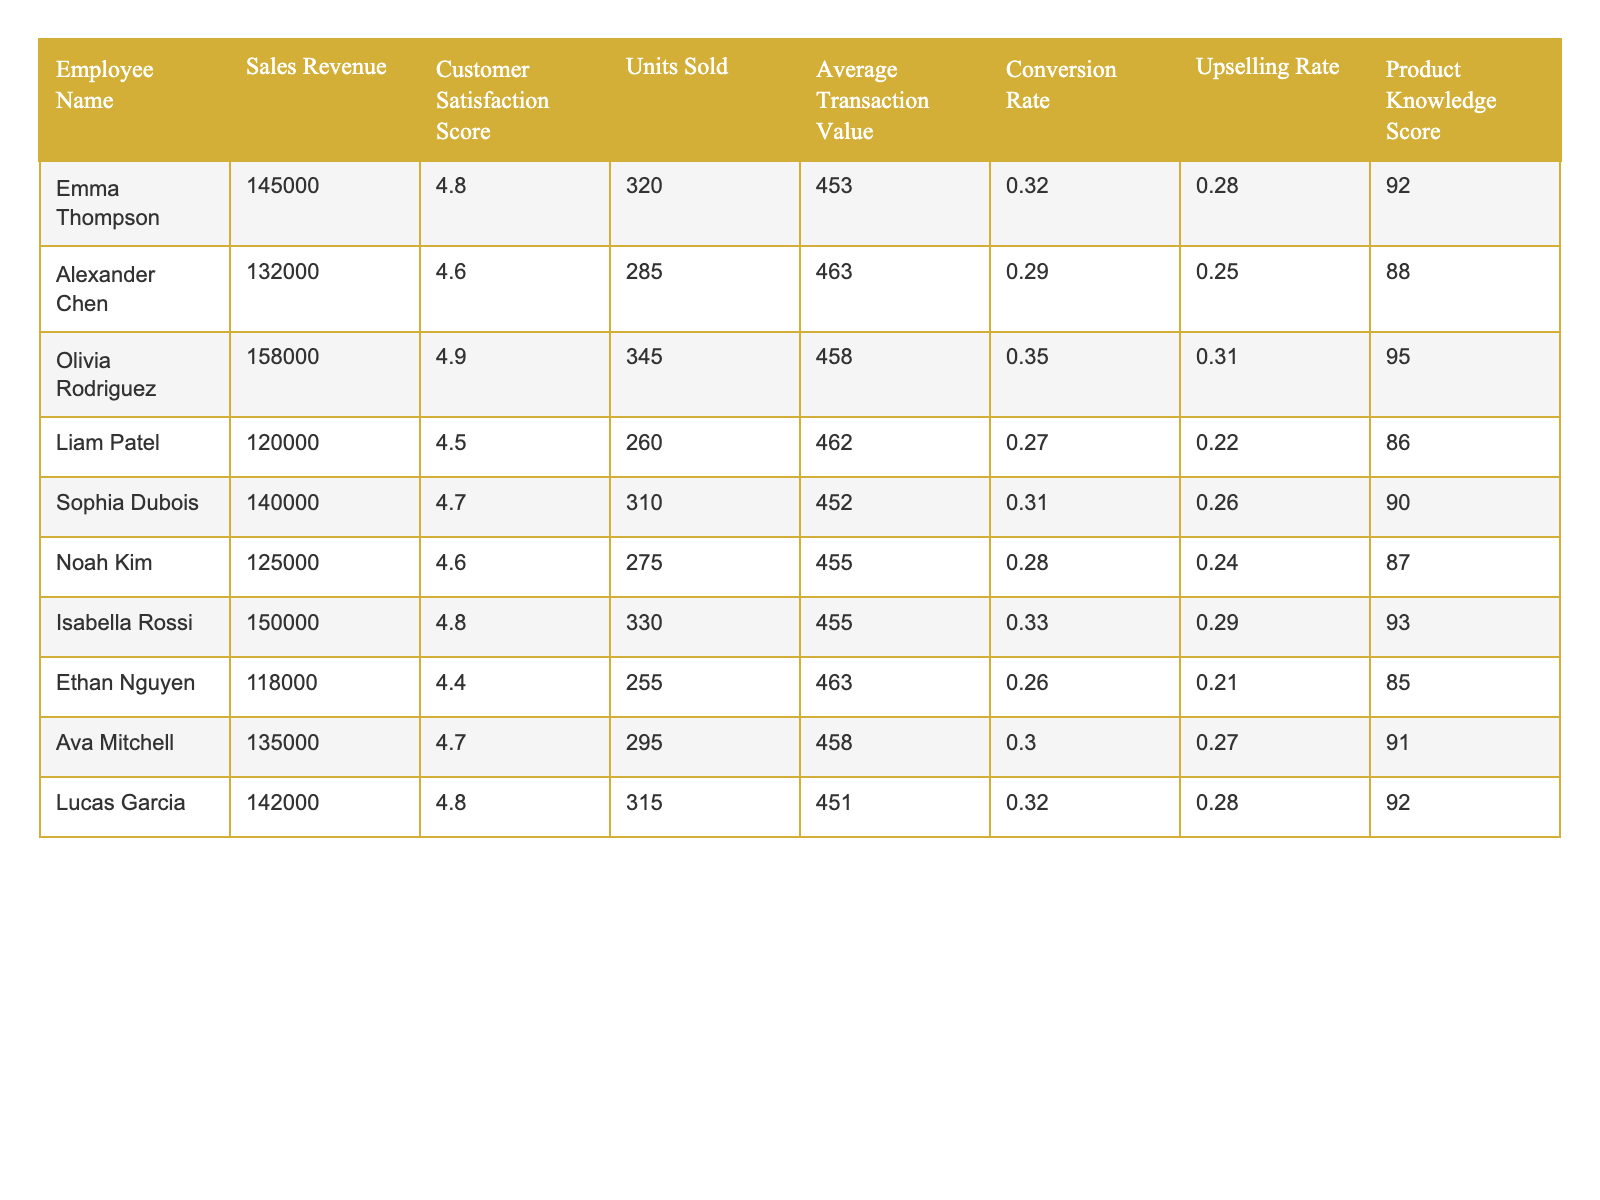What is the sales revenue of Olivia Rodriguez? The table indicates that Olivia Rodriguez has a sales revenue of 158000.
Answer: 158000 Who has the highest customer satisfaction score? According to the table, Olivia Rodriguez has the highest customer satisfaction score of 4.9.
Answer: 4.9 What is the average transaction value for Emma Thompson? The table shows that the average transaction value for Emma Thompson is 453.
Answer: 453 How many units did Liam Patel sell? The data in the table shows that Liam Patel sold 260 units.
Answer: 260 What is the conversion rate for Isabella Rossi? The table states that Isabella Rossi has a conversion rate of 0.33.
Answer: 0.33 What is the total sales revenue generated by the top three sales associates? Summing up the sales revenue of the top three associates: 158000 (Olivia) + 150000 (Isabella) + 145000 (Emma) gives 453000.
Answer: 453000 Is the average customer satisfaction score for the employees above 4.6? To find the average, we calculate: (4.8 + 4.6 + 4.9 + 4.5 + 4.7 + 4.6 + 4.8 + 4.4 + 4.7 + 4.8) / 10 = 4.66, which is below 4.6. So, the answer is no.
Answer: No Who has the highest upselling rate and what is it? From the table, Isabella Rossi has the highest upselling rate of 0.29.
Answer: 0.29 If we consider the conversion rates of all employees, what is the overall average conversion rate? Adding up all conversion rates: 0.32 + 0.29 + 0.35 + 0.27 + 0.31 + 0.28 + 0.33 + 0.26 + 0.30 + 0.32 gives 3.29. Dividing by 10 gives an average conversion rate of 0.329.
Answer: 0.329 What is the difference in sales revenue between the highest and lowest salesperson? The highest sales revenue is 158000 (Olivia) and the lowest is 118000 (Ethan), so the difference is 158000 - 118000 = 40000.
Answer: 40000 